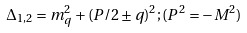Convert formula to latex. <formula><loc_0><loc_0><loc_500><loc_500>\Delta _ { 1 , 2 } = m _ { q } ^ { 2 } + ( P / 2 \pm q ) ^ { 2 } ; ( P ^ { 2 } = - M ^ { 2 } )</formula> 